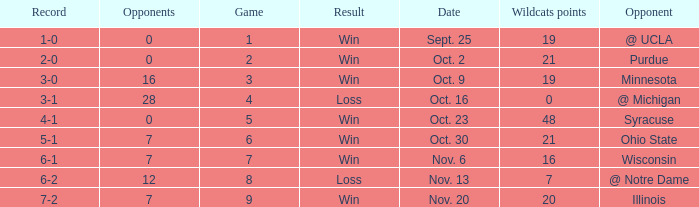What game number did the Wildcats play Purdue? 2.0. 